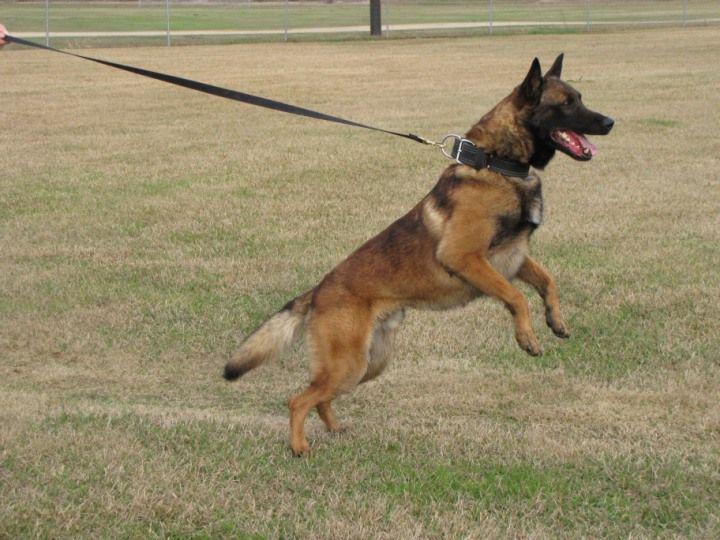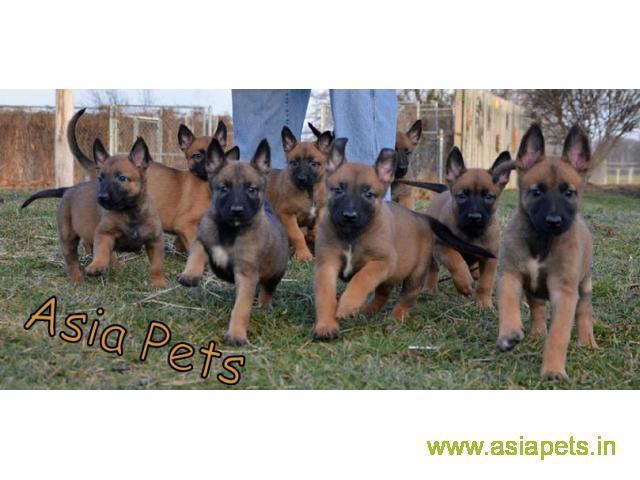The first image is the image on the left, the second image is the image on the right. Given the left and right images, does the statement "There are at most five dogs." hold true? Answer yes or no. No. 